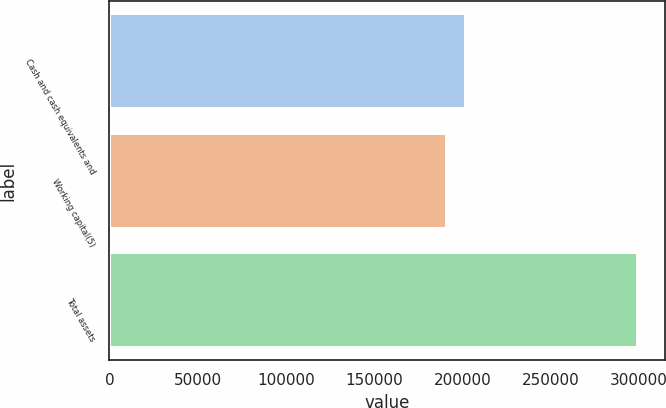<chart> <loc_0><loc_0><loc_500><loc_500><bar_chart><fcel>Cash and cash equivalents and<fcel>Working capital(5)<fcel>Total assets<nl><fcel>202286<fcel>191482<fcel>299521<nl></chart> 